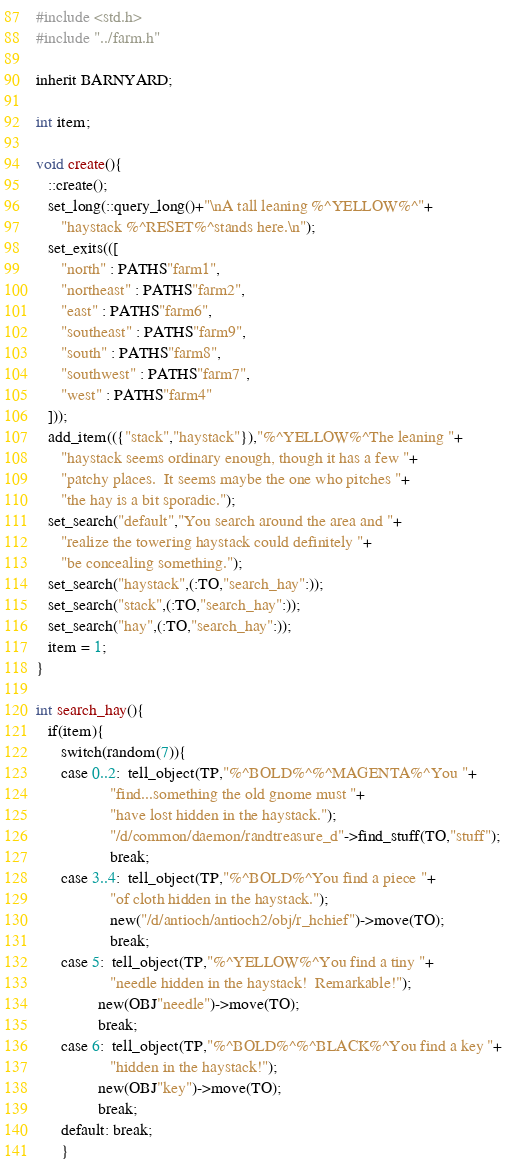Convert code to text. <code><loc_0><loc_0><loc_500><loc_500><_C_>#include <std.h>
#include "../farm.h"

inherit BARNYARD;

int item;

void create(){
   ::create();
   set_long(::query_long()+"\nA tall leaning %^YELLOW%^"+
      "haystack %^RESET%^stands here.\n");
   set_exits(([
      "north" : PATHS"farm1",
      "northeast" : PATHS"farm2",
      "east" : PATHS"farm6",
      "southeast" : PATHS"farm9",
      "south" : PATHS"farm8",
      "southwest" : PATHS"farm7",
      "west" : PATHS"farm4"
   ]));
   add_item(({"stack","haystack"}),"%^YELLOW%^The leaning "+
      "haystack seems ordinary enough, though it has a few "+
      "patchy places.  It seems maybe the one who pitches "+
      "the hay is a bit sporadic.");
   set_search("default","You search around the area and "+
      "realize the towering haystack could definitely "+
      "be concealing something.");
   set_search("haystack",(:TO,"search_hay":));
   set_search("stack",(:TO,"search_hay":));
   set_search("hay",(:TO,"search_hay":));
   item = 1;
}

int search_hay(){
   if(item){
      switch(random(7)){
      case 0..2:  tell_object(TP,"%^BOLD%^%^MAGENTA%^You "+
                  "find...something the old gnome must "+
                  "have lost hidden in the haystack.");
                  "/d/common/daemon/randtreasure_d"->find_stuff(TO,"stuff");
                  break;
      case 3..4:  tell_object(TP,"%^BOLD%^You find a piece "+
                  "of cloth hidden in the haystack.");
                  new("/d/antioch/antioch2/obj/r_hchief")->move(TO);
                  break;
      case 5:  tell_object(TP,"%^YELLOW%^You find a tiny "+
                  "needle hidden in the haystack!  Remarkable!");
               new(OBJ"needle")->move(TO);
               break;
      case 6:  tell_object(TP,"%^BOLD%^%^BLACK%^You find a key "+
                  "hidden in the haystack!");
               new(OBJ"key")->move(TO);
               break;
      default: break;
      }</code> 